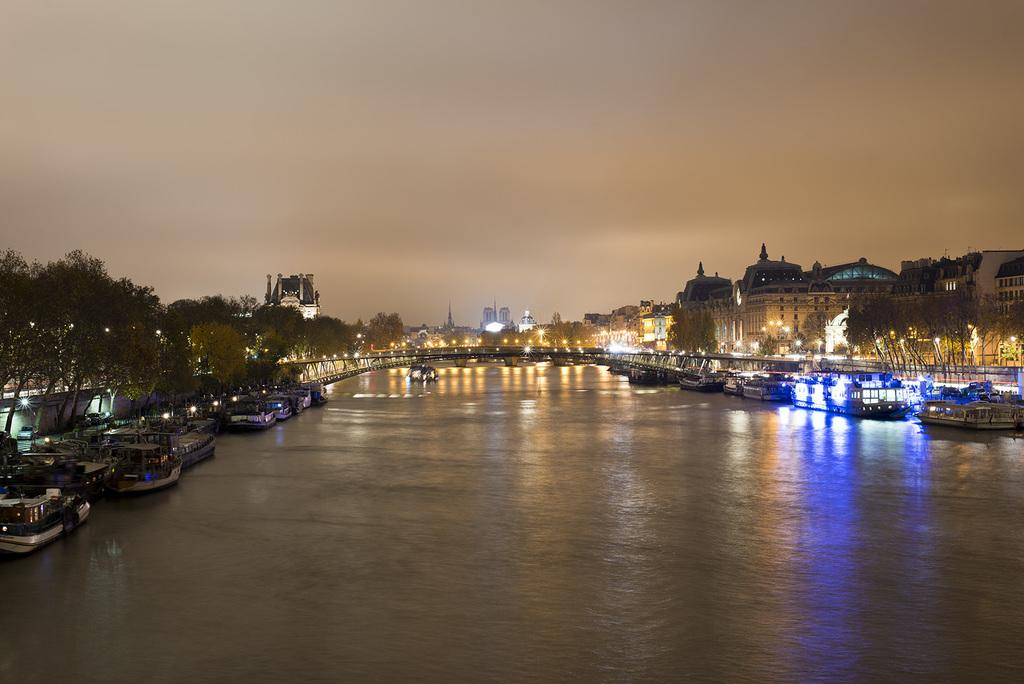What is on the water in the image? There are boats on the water in the image. What can be seen in the distance behind the boats? There are buildings, trees, and street lights in the background of the image. What else is visible in the background of the image? There are other unspecified objects in the background of the image. What is visible above the boats and background? The sky is visible in the image. How many attempts does the death roll make in the image? There is no reference to a death roll or any death-related activity in the image. 